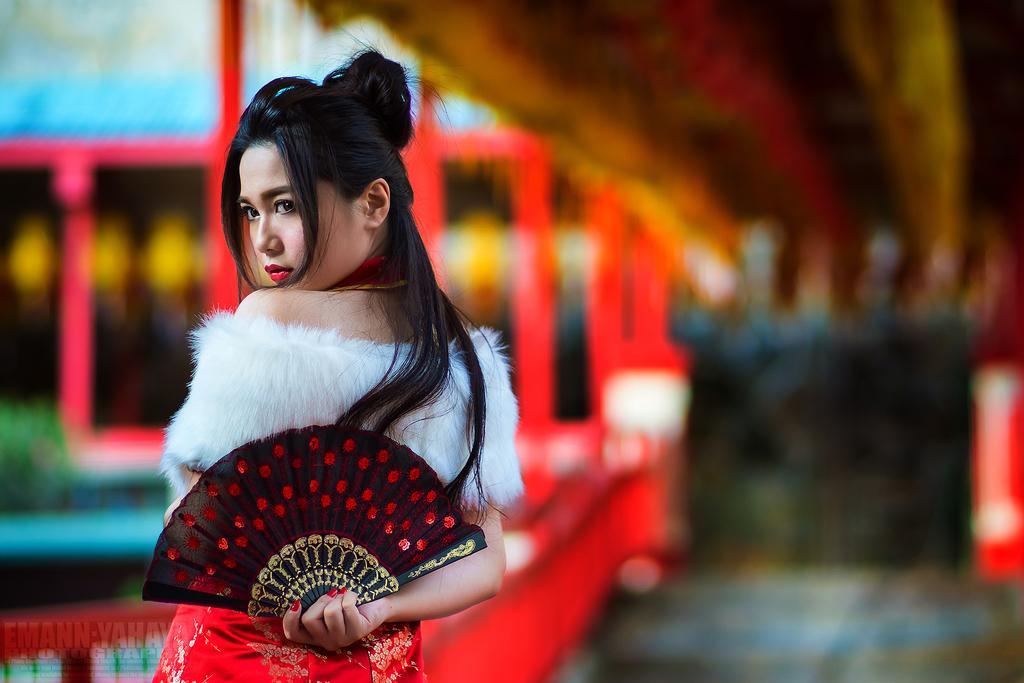Describe this image in one or two sentences. In this image there is a lady standing and holding a hand fan. The background is blurry. 